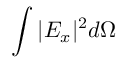<formula> <loc_0><loc_0><loc_500><loc_500>\int { | E _ { x } | ^ { 2 } d \Omega }</formula> 